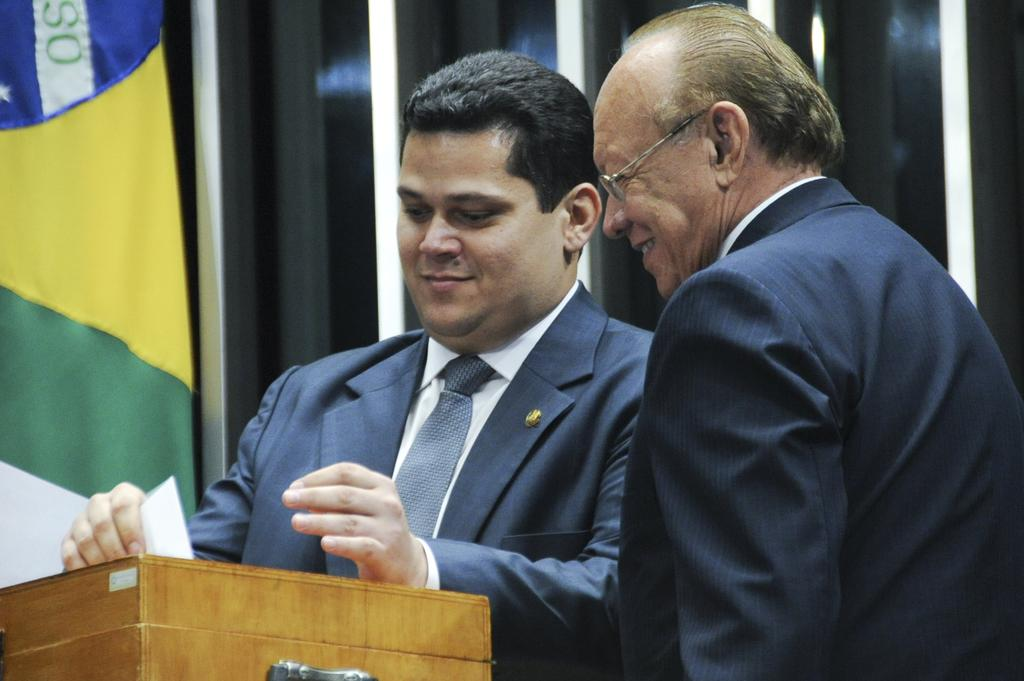How many people are in the image? There are two persons standing in the center of the image. What is the facial expression of the persons? The persons are smiling. What is located in front of the persons? There is a wooden stand in front of the persons. What can be seen in the background of the image? There is a wall and a curtain in the background of the image. Can you see any lizards resting on the wall in the image? There are no lizards present in the image. What type of river can be seen flowing behind the persons in the image? There is no river visible in the image; it only features a wall and a curtain in the background. 